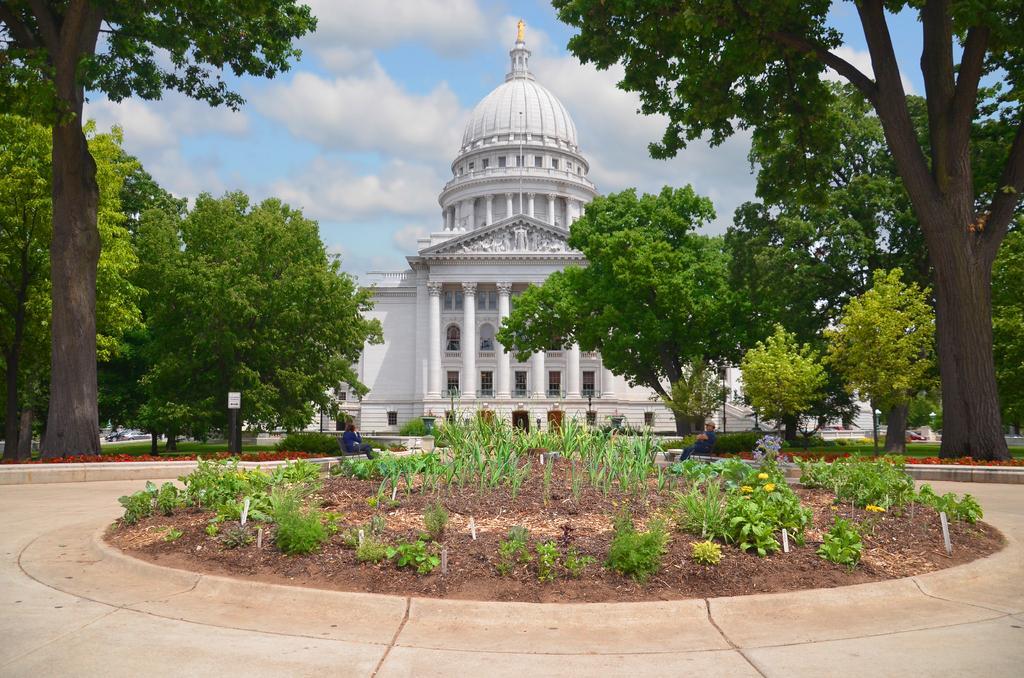Could you give a brief overview of what you see in this image? In the foreground I can see flowering plants, grass, fence, pillars, boards, two persons are sitting and trees. In the background I can see a building, pillars, windows and the sky. This image is taken may be during a day. 